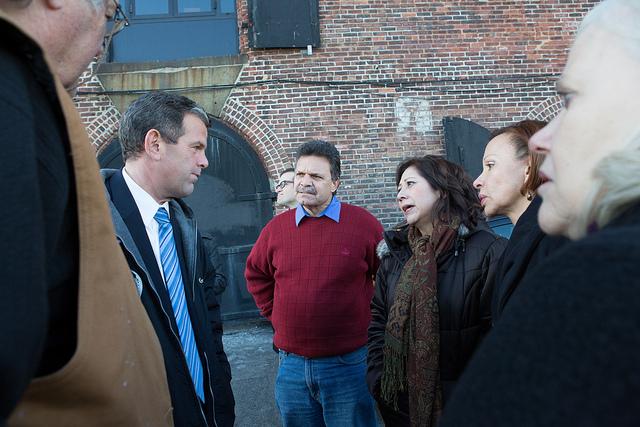What kind of pants is the woman wearing?
Keep it brief. Jeans. What is the color of the shirt the man with the mustache has on?
Write a very short answer. Red. Do we look like we are from the same family?
Write a very short answer. Yes. Could the man with the blue tie be a politician?
Concise answer only. Yes. What is the title of the man in black?
Give a very brief answer. Lawyer. How many people are present for this photograph?
Keep it brief. 6. Is anyone wearing a hat?
Concise answer only. No. What is on the man's head?
Give a very brief answer. Hair. Are they happy?
Keep it brief. No. Is that woman flicking me off?
Concise answer only. No. 